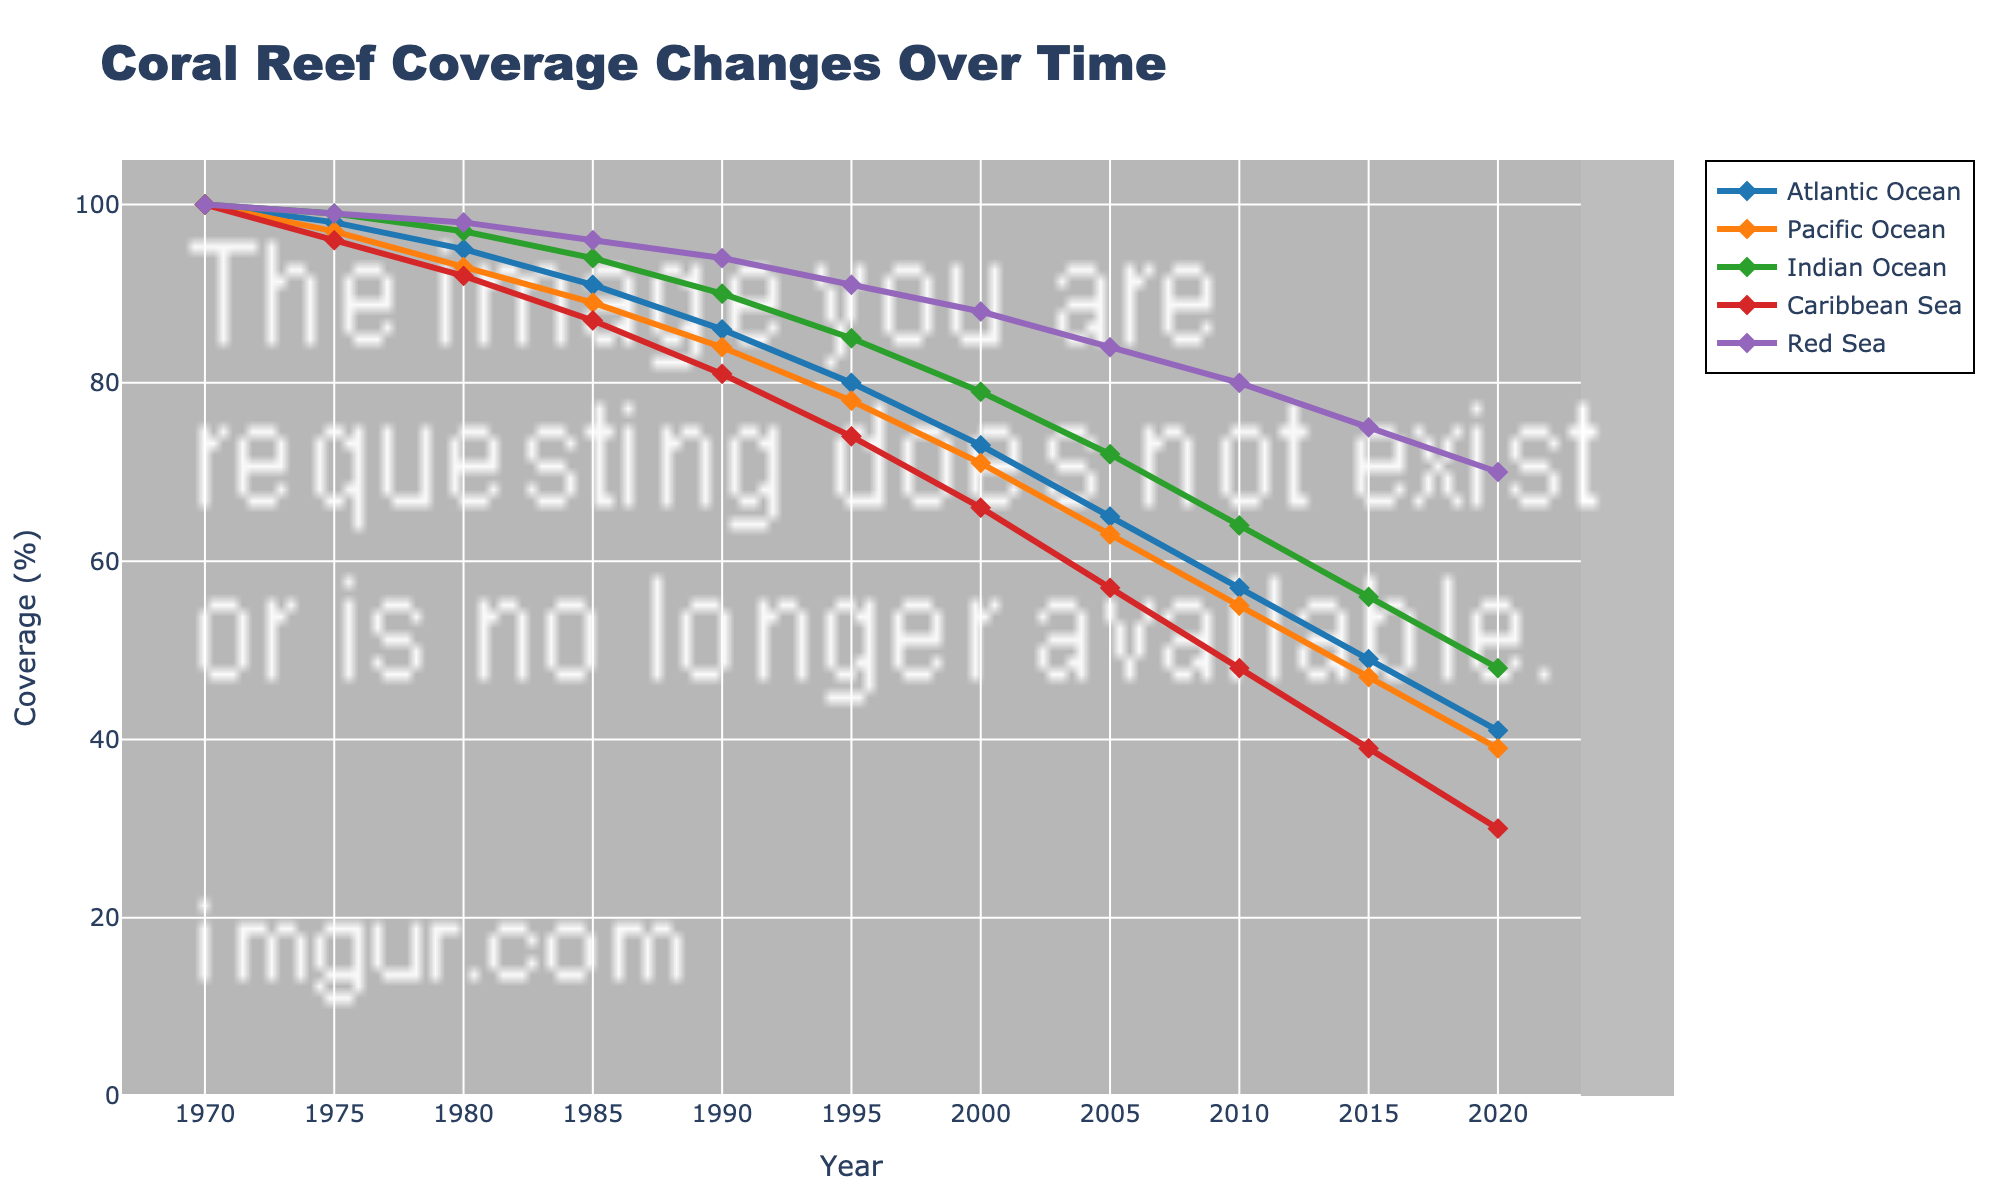what year does the Atlantic Ocean coral reef coverage drop below 50%? Analyze the line for the Atlantic Ocean (blue line) and observe its trend over time. The coverage drops below 50% around 2015.
Answer: 2015 Which ocean basin maintains the highest coral reef coverage in 2020? Examine the endpoint of the lines for 2020 and compare their vertical positions. The Red Sea (purple line) has the highest coverage at approximately 70%.
Answer: Red Sea What's the difference in coral reef coverage between the Indian Ocean and the Caribbean Sea in 2010? Locate the points for 2010 on the lines for the Indian Ocean (green line) and the Caribbean Sea (red line), and calculate the difference in their vertical positions. Indian Ocean: ~64%, Caribbean Sea: ~48%. The difference is 64 - 48 = 16%.
Answer: 16% Which ocean has the steepest decline in coral reef coverage between 1970 and 2020? Assess the slope of each line from 1970 to 2020. The Pacific Ocean (orange line) appears to have the steepest decline as it drops from 100% to 39%.
Answer: Pacific Ocean In which decade did the Caribbean Sea experience the largest drop in coral reef coverage? Analyze the line for the Caribbean Sea (red line) and observe the vertical distance it covers in each decade. The biggest drop appears to be from 1995 to 2005, when it drops from around 74% to 57%.
Answer: 1995-2005 What's the average coral reef coverage for the Indian Ocean across all recorded years? To find the average, sum up all the values for the Indian Ocean and divide by the number of data points. (100 + 99 + 97 + 94 + 90 + 85 + 79 + 72 + 64 + 56 + 48) / 11 = 884 / 11 ≈ 80.36%.
Answer: ~80.36% How does the coral reef coverage of the Pacific Ocean in 2000 compare to that of the Atlantic Ocean in 1980? Compare the points for the Pacific Ocean in 2000 and the Atlantic Ocean in 1980. Pacific Ocean: ~71%, Atlantic Ocean: ~95%. The coverage of the Atlantic Ocean in 1980 is higher.
Answer: Atlantic Ocean is higher By how much did the coral reef coverage in the Red Sea decrease from 1970 to 2020? Calculate the vertical drop for the Red Sea (purple line) from its initial value in 1970 to its final value in 2020. Red Sea: 100% - 70% = 30%.
Answer: 30% Which ocean had a coral reef coverage closest to the global average in 1975? Calculate the global average for 1975 by summing the values for all oceans and dividing by the number of them. ((98+97+99+96+99)/5) = 97.8%. Check which ocean is closest to this average: The Indian Ocean at 99% is closest.
Answer: Indian Ocean 